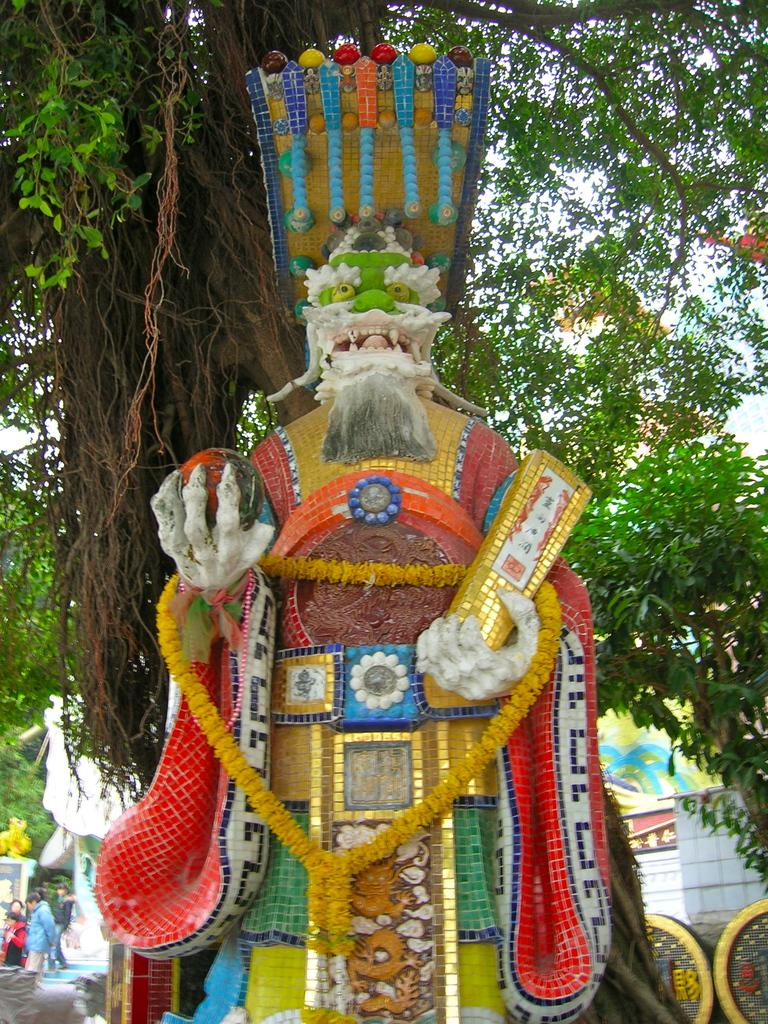What is the main subject in the center of the image? There is a statue in the center of the image. What can be seen in the background of the image? There are trees, houses, and people walking in the background of the image. How many crows are sitting on the statue in the image? There are no crows present in the image; the statue is the main subject in the center of the image. 